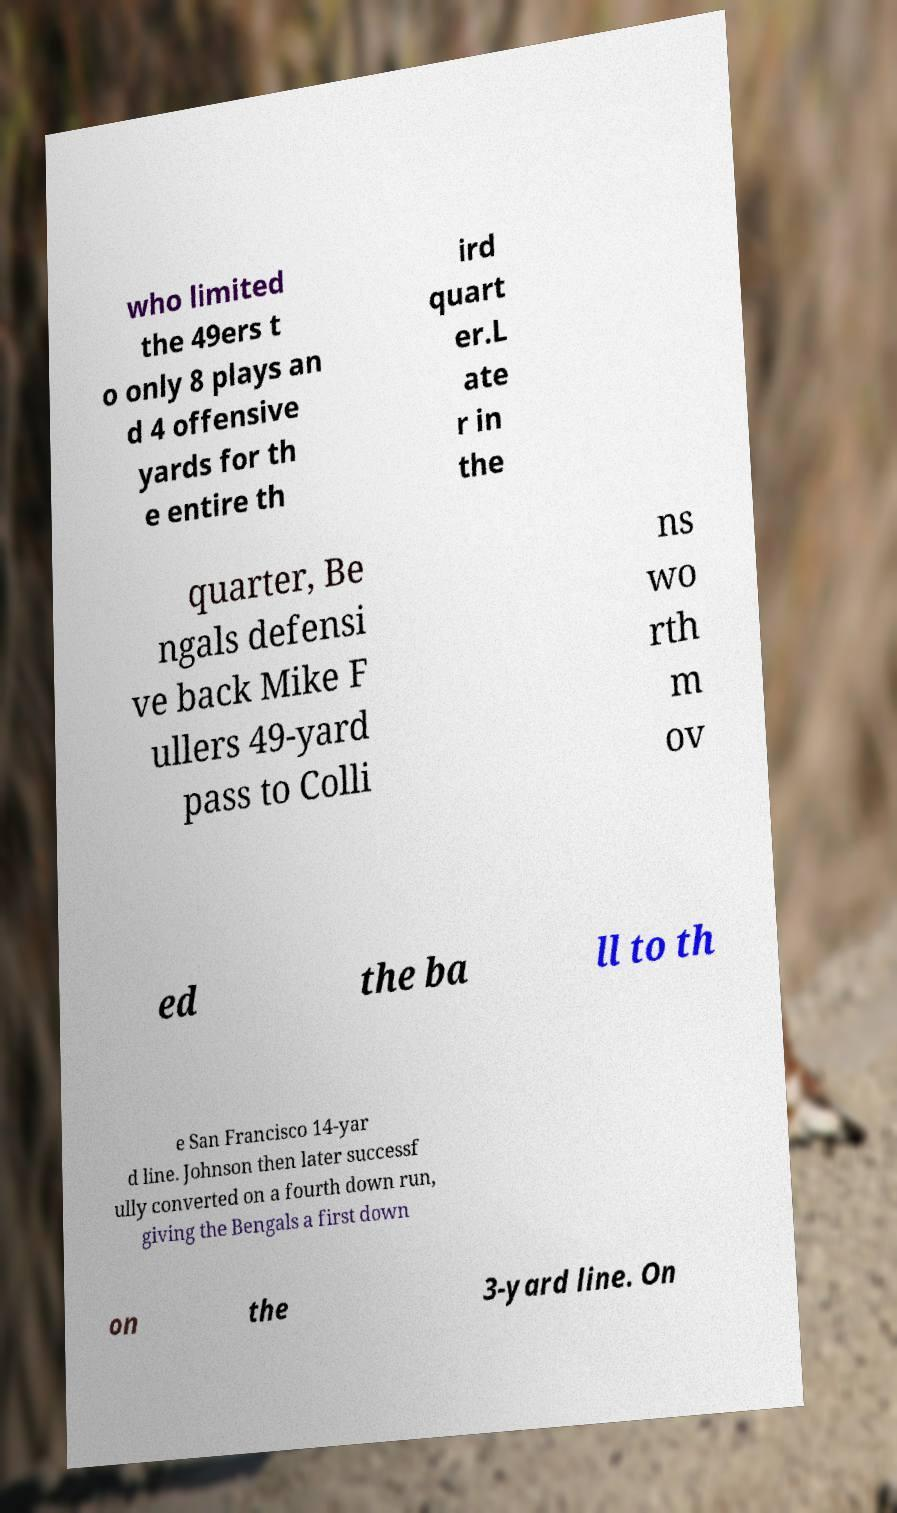Could you assist in decoding the text presented in this image and type it out clearly? who limited the 49ers t o only 8 plays an d 4 offensive yards for th e entire th ird quart er.L ate r in the quarter, Be ngals defensi ve back Mike F ullers 49-yard pass to Colli ns wo rth m ov ed the ba ll to th e San Francisco 14-yar d line. Johnson then later successf ully converted on a fourth down run, giving the Bengals a first down on the 3-yard line. On 